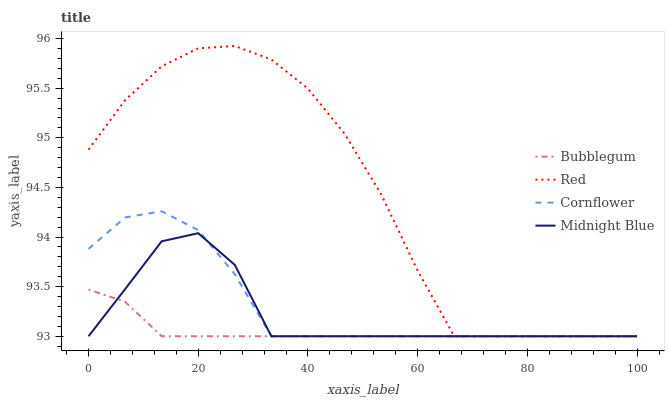Does Red have the minimum area under the curve?
Answer yes or no. No. Does Bubblegum have the maximum area under the curve?
Answer yes or no. No. Is Red the smoothest?
Answer yes or no. No. Is Bubblegum the roughest?
Answer yes or no. No. Does Bubblegum have the highest value?
Answer yes or no. No. 